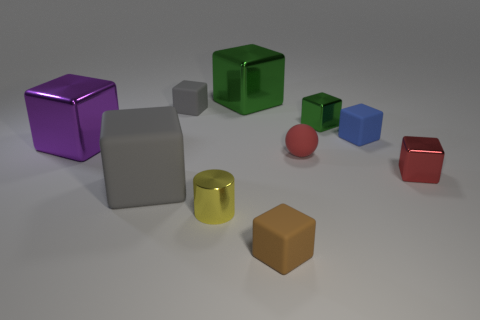Subtract all big cubes. How many cubes are left? 5 Subtract all brown blocks. How many blocks are left? 7 Subtract all spheres. How many objects are left? 9 Subtract all cyan blocks. Subtract all green cylinders. How many blocks are left? 8 Add 8 small metal cubes. How many small metal cubes are left? 10 Add 6 yellow shiny things. How many yellow shiny things exist? 7 Subtract 0 green balls. How many objects are left? 10 Subtract all small cyan balls. Subtract all red matte balls. How many objects are left? 9 